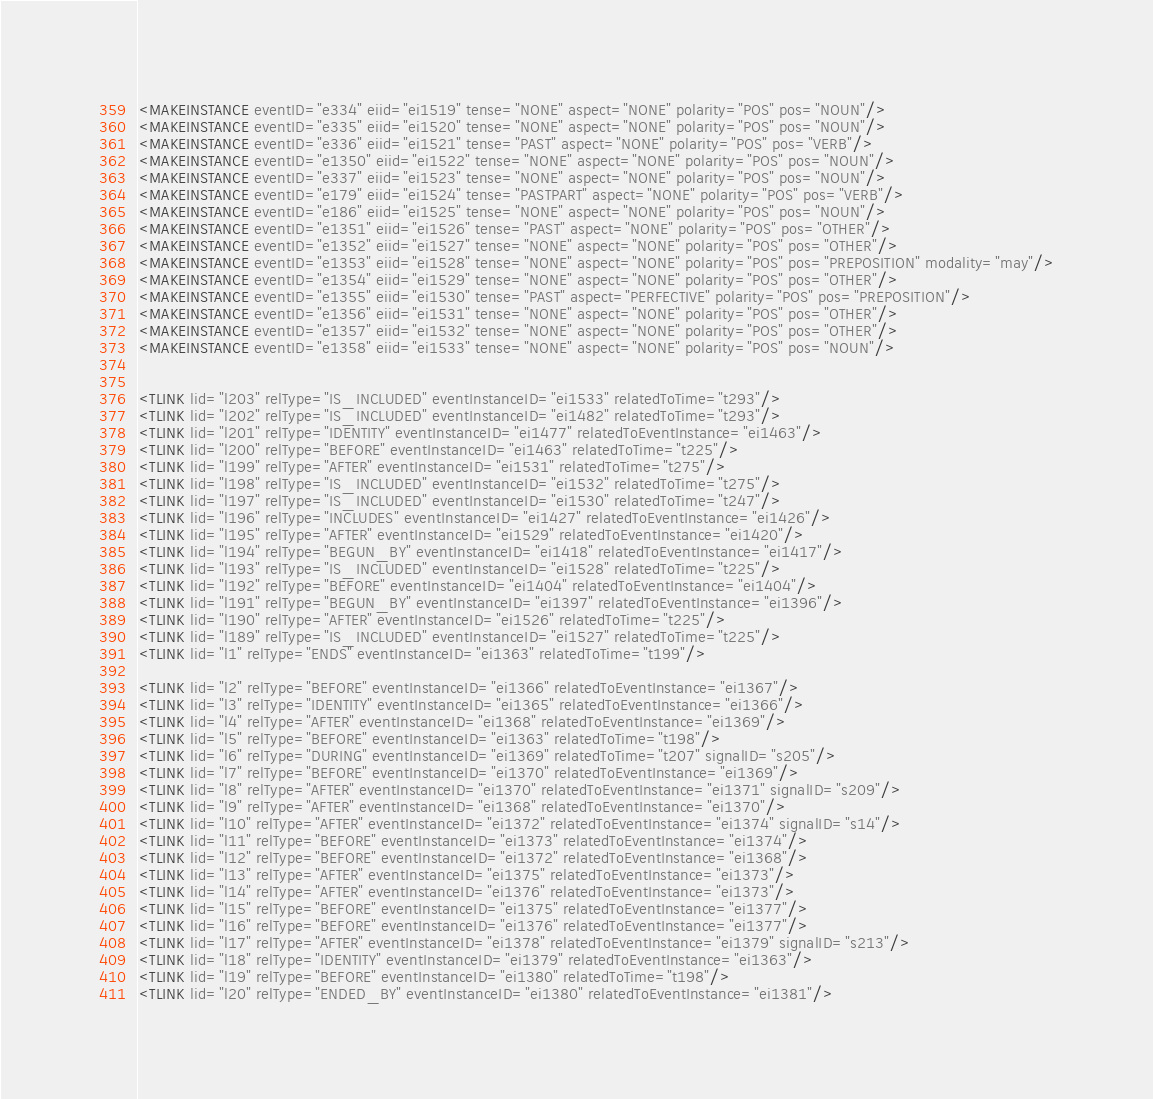Convert code to text. <code><loc_0><loc_0><loc_500><loc_500><_XML_><MAKEINSTANCE eventID="e334" eiid="ei1519" tense="NONE" aspect="NONE" polarity="POS" pos="NOUN"/>
<MAKEINSTANCE eventID="e335" eiid="ei1520" tense="NONE" aspect="NONE" polarity="POS" pos="NOUN"/>
<MAKEINSTANCE eventID="e336" eiid="ei1521" tense="PAST" aspect="NONE" polarity="POS" pos="VERB"/>
<MAKEINSTANCE eventID="e1350" eiid="ei1522" tense="NONE" aspect="NONE" polarity="POS" pos="NOUN"/>
<MAKEINSTANCE eventID="e337" eiid="ei1523" tense="NONE" aspect="NONE" polarity="POS" pos="NOUN"/>
<MAKEINSTANCE eventID="e179" eiid="ei1524" tense="PASTPART" aspect="NONE" polarity="POS" pos="VERB"/>
<MAKEINSTANCE eventID="e186" eiid="ei1525" tense="NONE" aspect="NONE" polarity="POS" pos="NOUN"/>
<MAKEINSTANCE eventID="e1351" eiid="ei1526" tense="PAST" aspect="NONE" polarity="POS" pos="OTHER"/>
<MAKEINSTANCE eventID="e1352" eiid="ei1527" tense="NONE" aspect="NONE" polarity="POS" pos="OTHER"/>
<MAKEINSTANCE eventID="e1353" eiid="ei1528" tense="NONE" aspect="NONE" polarity="POS" pos="PREPOSITION" modality="may"/>
<MAKEINSTANCE eventID="e1354" eiid="ei1529" tense="NONE" aspect="NONE" polarity="POS" pos="OTHER"/>
<MAKEINSTANCE eventID="e1355" eiid="ei1530" tense="PAST" aspect="PERFECTIVE" polarity="POS" pos="PREPOSITION"/>
<MAKEINSTANCE eventID="e1356" eiid="ei1531" tense="NONE" aspect="NONE" polarity="POS" pos="OTHER"/>
<MAKEINSTANCE eventID="e1357" eiid="ei1532" tense="NONE" aspect="NONE" polarity="POS" pos="OTHER"/>
<MAKEINSTANCE eventID="e1358" eiid="ei1533" tense="NONE" aspect="NONE" polarity="POS" pos="NOUN"/>


<TLINK lid="l203" relType="IS_INCLUDED" eventInstanceID="ei1533" relatedToTime="t293"/>
<TLINK lid="l202" relType="IS_INCLUDED" eventInstanceID="ei1482" relatedToTime="t293"/>
<TLINK lid="l201" relType="IDENTITY" eventInstanceID="ei1477" relatedToEventInstance="ei1463"/>
<TLINK lid="l200" relType="BEFORE" eventInstanceID="ei1463" relatedToTime="t225"/>
<TLINK lid="l199" relType="AFTER" eventInstanceID="ei1531" relatedToTime="t275"/>
<TLINK lid="l198" relType="IS_INCLUDED" eventInstanceID="ei1532" relatedToTime="t275"/>
<TLINK lid="l197" relType="IS_INCLUDED" eventInstanceID="ei1530" relatedToTime="t247"/>
<TLINK lid="l196" relType="INCLUDES" eventInstanceID="ei1427" relatedToEventInstance="ei1426"/>
<TLINK lid="l195" relType="AFTER" eventInstanceID="ei1529" relatedToEventInstance="ei1420"/>
<TLINK lid="l194" relType="BEGUN_BY" eventInstanceID="ei1418" relatedToEventInstance="ei1417"/>
<TLINK lid="l193" relType="IS_INCLUDED" eventInstanceID="ei1528" relatedToTime="t225"/>
<TLINK lid="l192" relType="BEFORE" eventInstanceID="ei1404" relatedToEventInstance="ei1404"/>
<TLINK lid="l191" relType="BEGUN_BY" eventInstanceID="ei1397" relatedToEventInstance="ei1396"/>
<TLINK lid="l190" relType="AFTER" eventInstanceID="ei1526" relatedToTime="t225"/>
<TLINK lid="l189" relType="IS_INCLUDED" eventInstanceID="ei1527" relatedToTime="t225"/>
<TLINK lid="l1" relType="ENDS" eventInstanceID="ei1363" relatedToTime="t199"/>

<TLINK lid="l2" relType="BEFORE" eventInstanceID="ei1366" relatedToEventInstance="ei1367"/>
<TLINK lid="l3" relType="IDENTITY" eventInstanceID="ei1365" relatedToEventInstance="ei1366"/>
<TLINK lid="l4" relType="AFTER" eventInstanceID="ei1368" relatedToEventInstance="ei1369"/>
<TLINK lid="l5" relType="BEFORE" eventInstanceID="ei1363" relatedToTime="t198"/>
<TLINK lid="l6" relType="DURING" eventInstanceID="ei1369" relatedToTime="t207" signalID="s205"/>
<TLINK lid="l7" relType="BEFORE" eventInstanceID="ei1370" relatedToEventInstance="ei1369"/>
<TLINK lid="l8" relType="AFTER" eventInstanceID="ei1370" relatedToEventInstance="ei1371" signalID="s209"/>
<TLINK lid="l9" relType="AFTER" eventInstanceID="ei1368" relatedToEventInstance="ei1370"/>
<TLINK lid="l10" relType="AFTER" eventInstanceID="ei1372" relatedToEventInstance="ei1374" signalID="s14"/>
<TLINK lid="l11" relType="BEFORE" eventInstanceID="ei1373" relatedToEventInstance="ei1374"/>
<TLINK lid="l12" relType="BEFORE" eventInstanceID="ei1372" relatedToEventInstance="ei1368"/>
<TLINK lid="l13" relType="AFTER" eventInstanceID="ei1375" relatedToEventInstance="ei1373"/>
<TLINK lid="l14" relType="AFTER" eventInstanceID="ei1376" relatedToEventInstance="ei1373"/>
<TLINK lid="l15" relType="BEFORE" eventInstanceID="ei1375" relatedToEventInstance="ei1377"/>
<TLINK lid="l16" relType="BEFORE" eventInstanceID="ei1376" relatedToEventInstance="ei1377"/>
<TLINK lid="l17" relType="AFTER" eventInstanceID="ei1378" relatedToEventInstance="ei1379" signalID="s213"/>
<TLINK lid="l18" relType="IDENTITY" eventInstanceID="ei1379" relatedToEventInstance="ei1363"/>
<TLINK lid="l19" relType="BEFORE" eventInstanceID="ei1380" relatedToTime="t198"/>
<TLINK lid="l20" relType="ENDED_BY" eventInstanceID="ei1380" relatedToEventInstance="ei1381"/></code> 